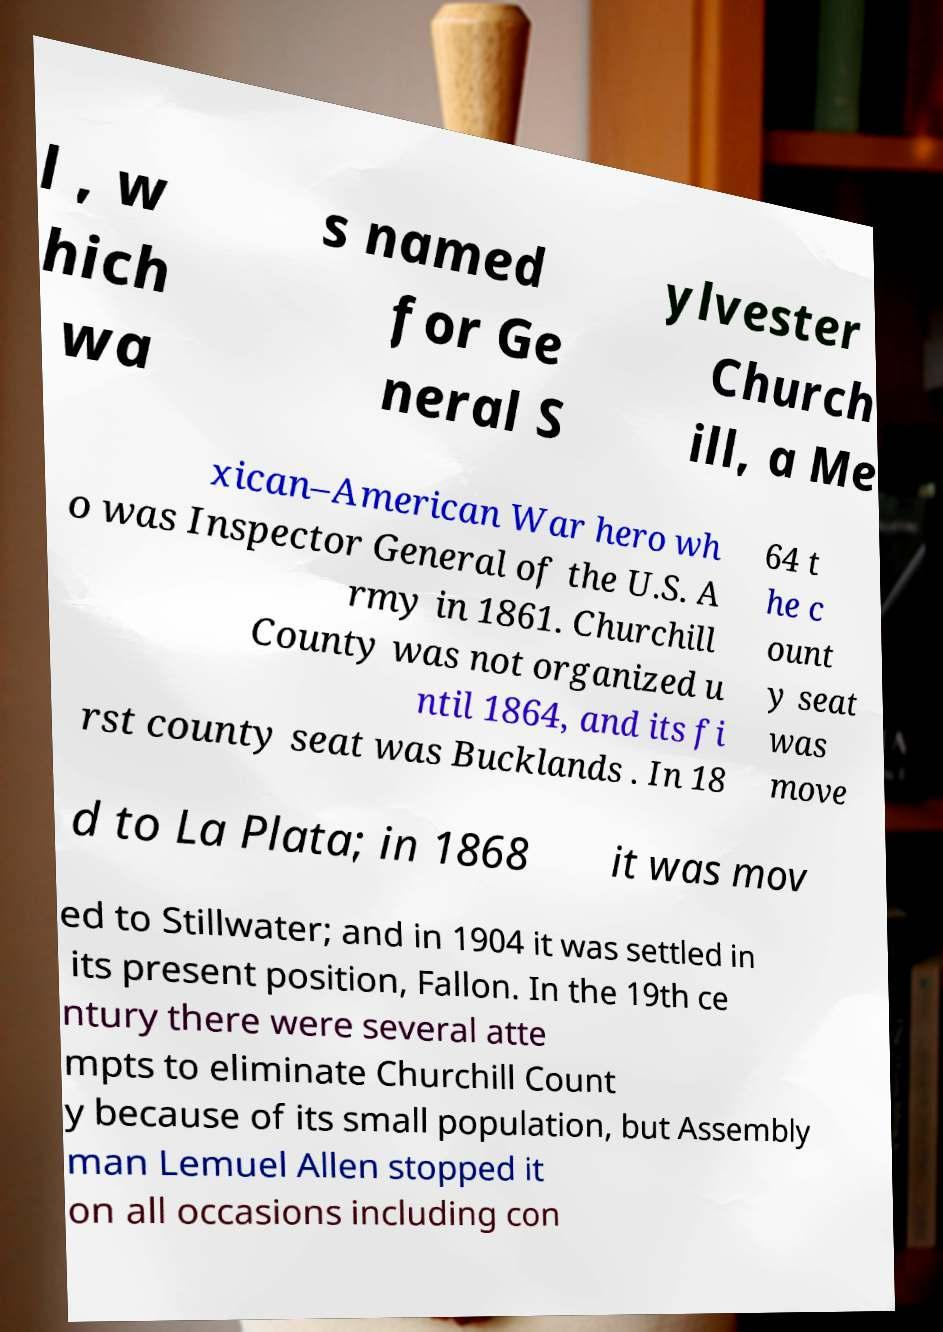Please identify and transcribe the text found in this image. l , w hich wa s named for Ge neral S ylvester Church ill, a Me xican–American War hero wh o was Inspector General of the U.S. A rmy in 1861. Churchill County was not organized u ntil 1864, and its fi rst county seat was Bucklands . In 18 64 t he c ount y seat was move d to La Plata; in 1868 it was mov ed to Stillwater; and in 1904 it was settled in its present position, Fallon. In the 19th ce ntury there were several atte mpts to eliminate Churchill Count y because of its small population, but Assembly man Lemuel Allen stopped it on all occasions including con 